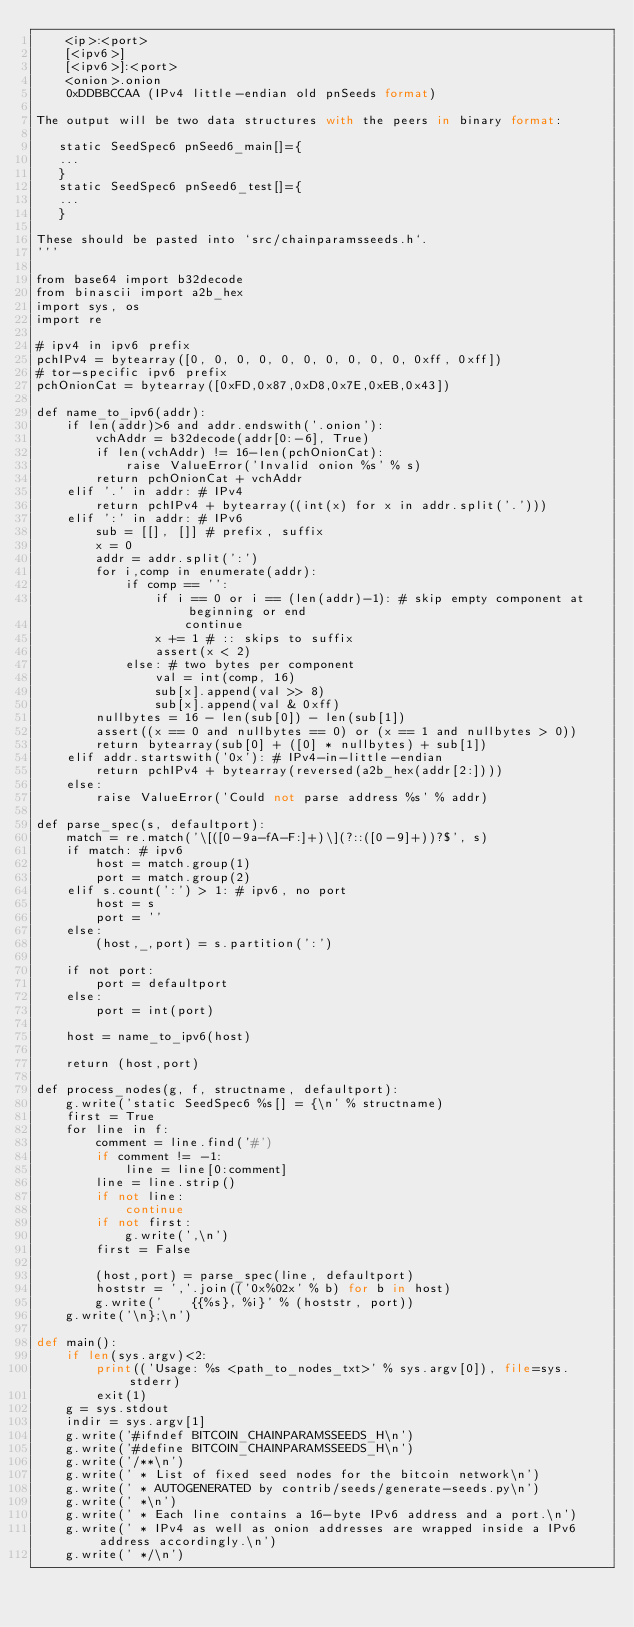Convert code to text. <code><loc_0><loc_0><loc_500><loc_500><_Python_>    <ip>:<port>
    [<ipv6>]
    [<ipv6>]:<port>
    <onion>.onion
    0xDDBBCCAA (IPv4 little-endian old pnSeeds format)

The output will be two data structures with the peers in binary format:

   static SeedSpec6 pnSeed6_main[]={
   ...
   }
   static SeedSpec6 pnSeed6_test[]={
   ...
   }

These should be pasted into `src/chainparamsseeds.h`.
'''

from base64 import b32decode
from binascii import a2b_hex
import sys, os
import re

# ipv4 in ipv6 prefix
pchIPv4 = bytearray([0, 0, 0, 0, 0, 0, 0, 0, 0, 0, 0xff, 0xff])
# tor-specific ipv6 prefix
pchOnionCat = bytearray([0xFD,0x87,0xD8,0x7E,0xEB,0x43])

def name_to_ipv6(addr):
    if len(addr)>6 and addr.endswith('.onion'):
        vchAddr = b32decode(addr[0:-6], True)
        if len(vchAddr) != 16-len(pchOnionCat):
            raise ValueError('Invalid onion %s' % s)
        return pchOnionCat + vchAddr
    elif '.' in addr: # IPv4
        return pchIPv4 + bytearray((int(x) for x in addr.split('.')))
    elif ':' in addr: # IPv6
        sub = [[], []] # prefix, suffix
        x = 0
        addr = addr.split(':')
        for i,comp in enumerate(addr):
            if comp == '':
                if i == 0 or i == (len(addr)-1): # skip empty component at beginning or end
                    continue
                x += 1 # :: skips to suffix
                assert(x < 2)
            else: # two bytes per component
                val = int(comp, 16)
                sub[x].append(val >> 8)
                sub[x].append(val & 0xff)
        nullbytes = 16 - len(sub[0]) - len(sub[1])
        assert((x == 0 and nullbytes == 0) or (x == 1 and nullbytes > 0))
        return bytearray(sub[0] + ([0] * nullbytes) + sub[1])
    elif addr.startswith('0x'): # IPv4-in-little-endian
        return pchIPv4 + bytearray(reversed(a2b_hex(addr[2:])))
    else:
        raise ValueError('Could not parse address %s' % addr)

def parse_spec(s, defaultport):
    match = re.match('\[([0-9a-fA-F:]+)\](?::([0-9]+))?$', s)
    if match: # ipv6
        host = match.group(1)
        port = match.group(2)
    elif s.count(':') > 1: # ipv6, no port
        host = s
        port = ''
    else:
        (host,_,port) = s.partition(':')

    if not port:
        port = defaultport
    else:
        port = int(port)

    host = name_to_ipv6(host)

    return (host,port)

def process_nodes(g, f, structname, defaultport):
    g.write('static SeedSpec6 %s[] = {\n' % structname)
    first = True
    for line in f:
        comment = line.find('#')
        if comment != -1:
            line = line[0:comment]
        line = line.strip()
        if not line:
            continue
        if not first:
            g.write(',\n')
        first = False

        (host,port) = parse_spec(line, defaultport)
        hoststr = ','.join(('0x%02x' % b) for b in host)
        g.write('    {{%s}, %i}' % (hoststr, port))
    g.write('\n};\n')

def main():
    if len(sys.argv)<2:
        print(('Usage: %s <path_to_nodes_txt>' % sys.argv[0]), file=sys.stderr)
        exit(1)
    g = sys.stdout
    indir = sys.argv[1]
    g.write('#ifndef BITCOIN_CHAINPARAMSSEEDS_H\n')
    g.write('#define BITCOIN_CHAINPARAMSSEEDS_H\n')
    g.write('/**\n')
    g.write(' * List of fixed seed nodes for the bitcoin network\n')
    g.write(' * AUTOGENERATED by contrib/seeds/generate-seeds.py\n')
    g.write(' *\n')
    g.write(' * Each line contains a 16-byte IPv6 address and a port.\n')
    g.write(' * IPv4 as well as onion addresses are wrapped inside a IPv6 address accordingly.\n')
    g.write(' */\n')</code> 